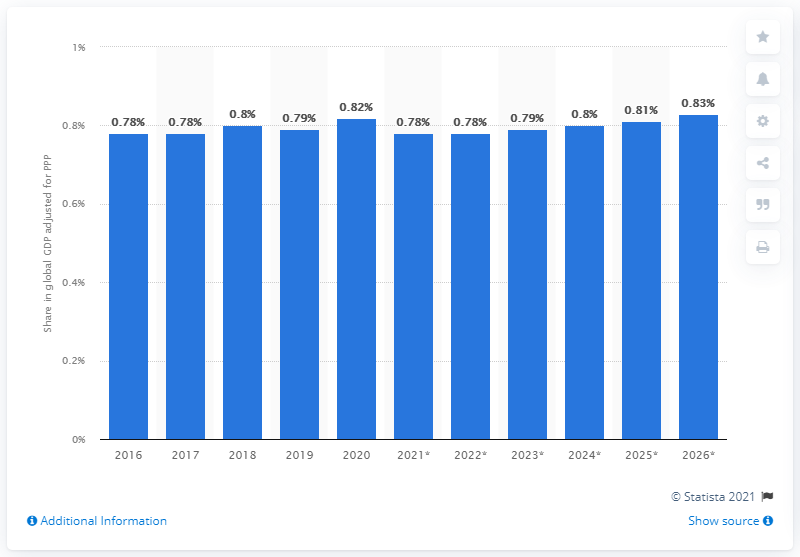Point out several critical features in this image. Pakistan's share of the global gross domestic product adjusted for purchasing power parity in 2020 was 0.82. As of 2026, the estimated adjusted Global Gross Domestic Product (GDP) for Pakistan, based on Purchasing Power Parity (PPP), is expected to end. 